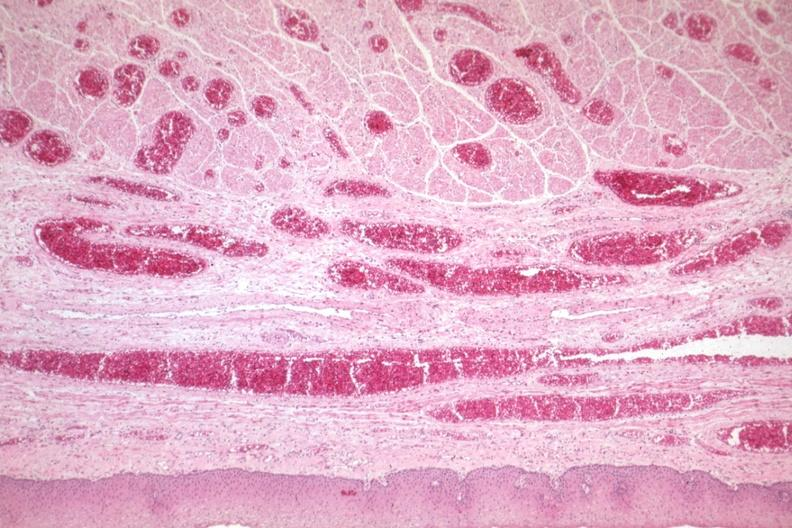s gastrointestinal present?
Answer the question using a single word or phrase. Yes 